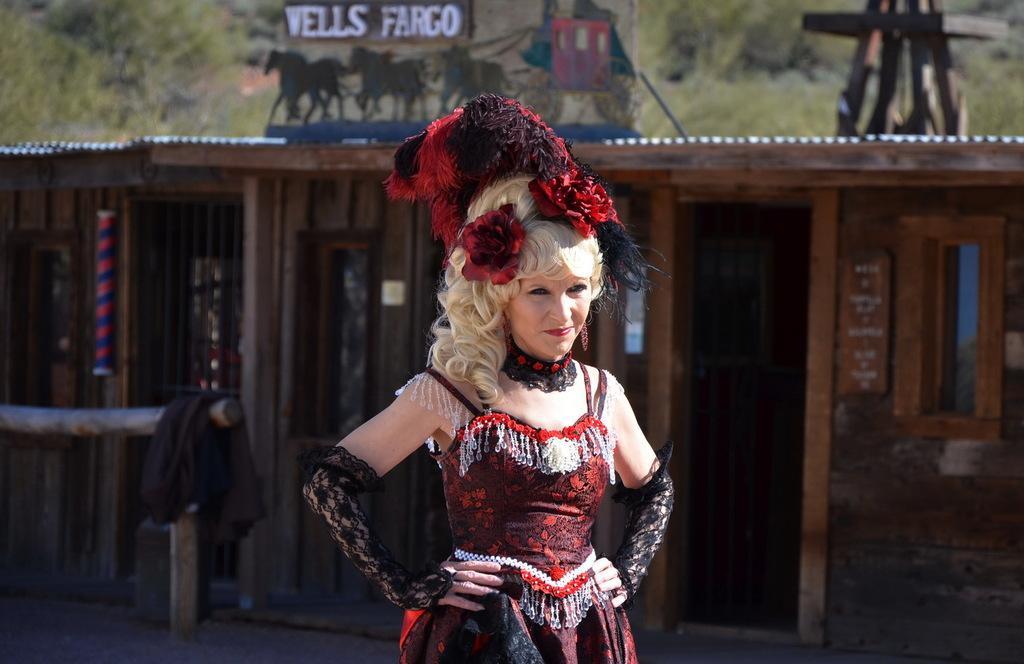Could you give a brief overview of what you see in this image? In this picture there is a woman standing and wore costume and we can see shade, cloth on wooden pole and board. In the background of the image it is blurry and we can see trees. 